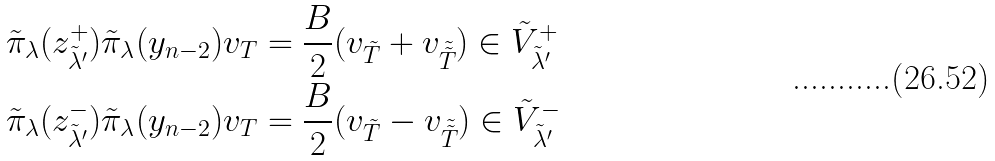<formula> <loc_0><loc_0><loc_500><loc_500>\tilde { \pi } _ { \lambda } ( z _ { \tilde { \lambda } ^ { \prime } } ^ { + } ) \tilde { \pi } _ { \lambda } ( y _ { n - 2 } ) v _ { T } & = \frac { B } { 2 } ( v _ { \tilde { T } } + v _ { \tilde { \tilde { T } } } ) \in \tilde { V } _ { \tilde { \lambda } ^ { \prime } } ^ { + } \\ \tilde { \pi } _ { \lambda } ( z _ { \tilde { \lambda } ^ { \prime } } ^ { - } ) \tilde { \pi } _ { \lambda } ( y _ { n - 2 } ) v _ { T } & = \frac { B } { 2 } ( v _ { \tilde { T } } - v _ { \tilde { \tilde { T } } } ) \in \tilde { V } _ { \tilde { \lambda } ^ { \prime } } ^ { - }</formula> 